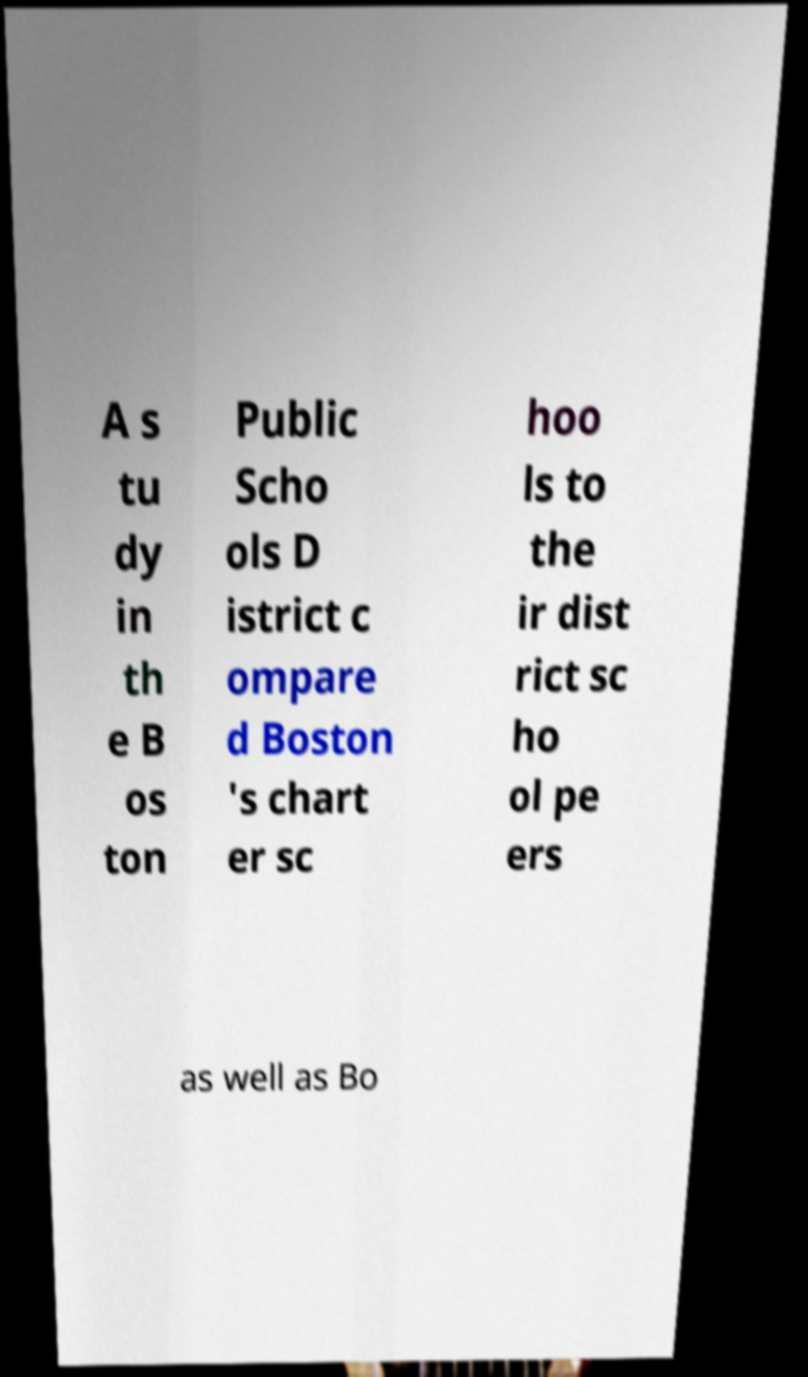Can you accurately transcribe the text from the provided image for me? A s tu dy in th e B os ton Public Scho ols D istrict c ompare d Boston 's chart er sc hoo ls to the ir dist rict sc ho ol pe ers as well as Bo 